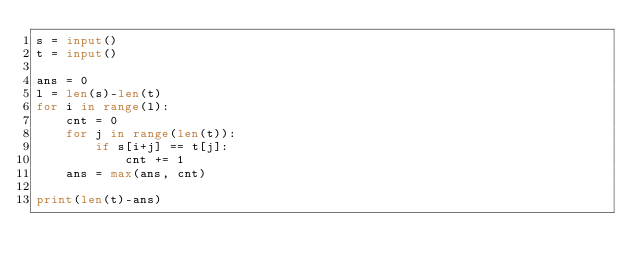Convert code to text. <code><loc_0><loc_0><loc_500><loc_500><_Python_>s = input()
t = input()

ans = 0
l = len(s)-len(t)
for i in range(l):
    cnt = 0
    for j in range(len(t)):
        if s[i+j] == t[j]:
            cnt += 1
    ans = max(ans, cnt)

print(len(t)-ans)</code> 